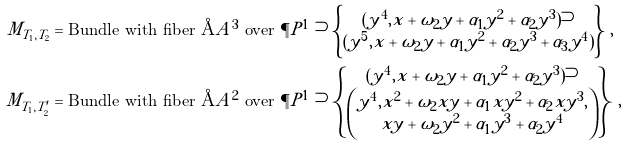Convert formula to latex. <formula><loc_0><loc_0><loc_500><loc_500>M _ { T _ { 1 } , T _ { 2 } } & = \text {Bundle with fiber } \AA A ^ { 3 } \text { over } \P P ^ { 1 } \supset \left \{ \begin{matrix} ( y ^ { 4 } , x + \omega _ { 2 } y + \alpha _ { 1 } y ^ { 2 } + \alpha _ { 2 } y ^ { 3 } ) \supset \\ ( y ^ { 5 } , x + \omega _ { 2 } y + \alpha _ { 1 } y ^ { 2 } + \alpha _ { 2 } y ^ { 3 } + \alpha _ { 3 } y ^ { 4 } ) \end{matrix} \right \} \, , \\ M _ { T _ { 1 } , T ^ { \prime } _ { 2 } } & = \text {Bundle with fiber } \AA A ^ { 2 } \text { over } \P P ^ { 1 } \supset \left \{ \begin{matrix} ( y ^ { 4 } , x + \omega _ { 2 } y + \alpha _ { 1 } y ^ { 2 } + \alpha _ { 2 } y ^ { 3 } ) \supset \\ \begin{pmatrix} y ^ { 4 } , x ^ { 2 } + \omega _ { 2 } x y + \alpha _ { 1 } x y ^ { 2 } + \alpha _ { 2 } x y ^ { 3 } , \\ x y + \omega _ { 2 } y ^ { 2 } + \alpha _ { 1 } y ^ { 3 } + \alpha _ { 2 } y ^ { 4 } \end{pmatrix} \end{matrix} \right \} \, ,</formula> 